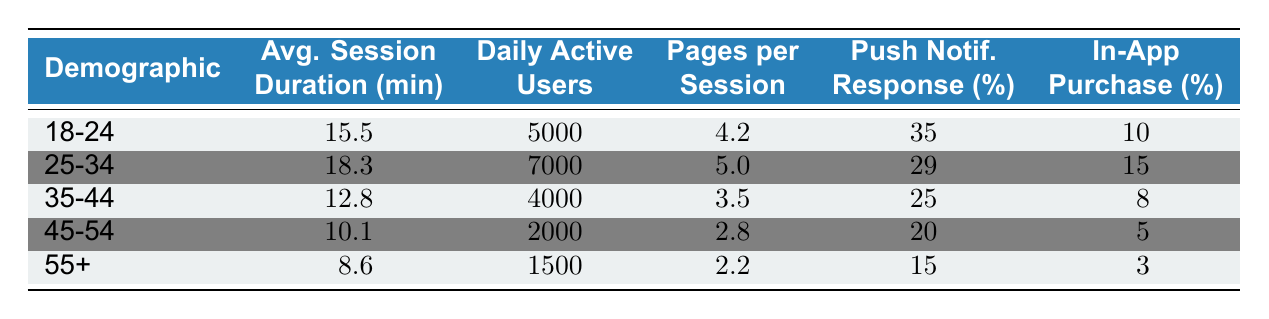What is the average session duration for the 25-34 demographic? The table shows that the average session duration for the 25-34 demographic is 18.3 minutes.
Answer: 18.3 How many daily active users are there in the 45-54 demographic? According to the table, the number of daily active users in the 45-54 demographic is 2000.
Answer: 2000 Which demographic has the highest pages per session? The 25-34 demographic has the highest pages per session with a value of 5.0.
Answer: 25-34 Is the push notification response rate for the 55+ demographic higher than that of the 35-44 demographic? The push notification response rate for the 55+ demographic is 15%, and for the 35-44 demographic, it's 25%. Therefore, it is NOT higher.
Answer: No What is the total number of daily active users across all demographics? To find the total, sum the daily active users: 5000 + 7000 + 4000 + 2000 + 1500 = 20000.
Answer: 20000 What is the average in-app purchase rate across all demographics? To find the average in-app purchase rate, sum the rates: 10 + 15 + 8 + 5 + 3 = 41, then divide by 5 (the number of demographics) to get 41/5 = 8.2.
Answer: 8.2 Which demographic has the lowest average session duration? The 55+ demographic has the lowest average session duration of 8.6 minutes.
Answer: 55+ Are there more daily active users in the 18-24 demographic compared to the 55+ demographic? The daily active users for the 18-24 demographic is 5000 and for the 55+ demographic is 1500, so there are more users in the 18-24 demographic.
Answer: Yes What is the difference in push notification response rate between the 18-24 and 45-54 demographics? The response rate for 18-24 is 35% and for 45-54 is 20%. The difference is 35 - 20 = 15.
Answer: 15 Which demographic has the highest in-app purchase rate, and how much is it? The 25-34 demographic has the highest in-app purchase rate at 15%.
Answer: 25-34, 15 